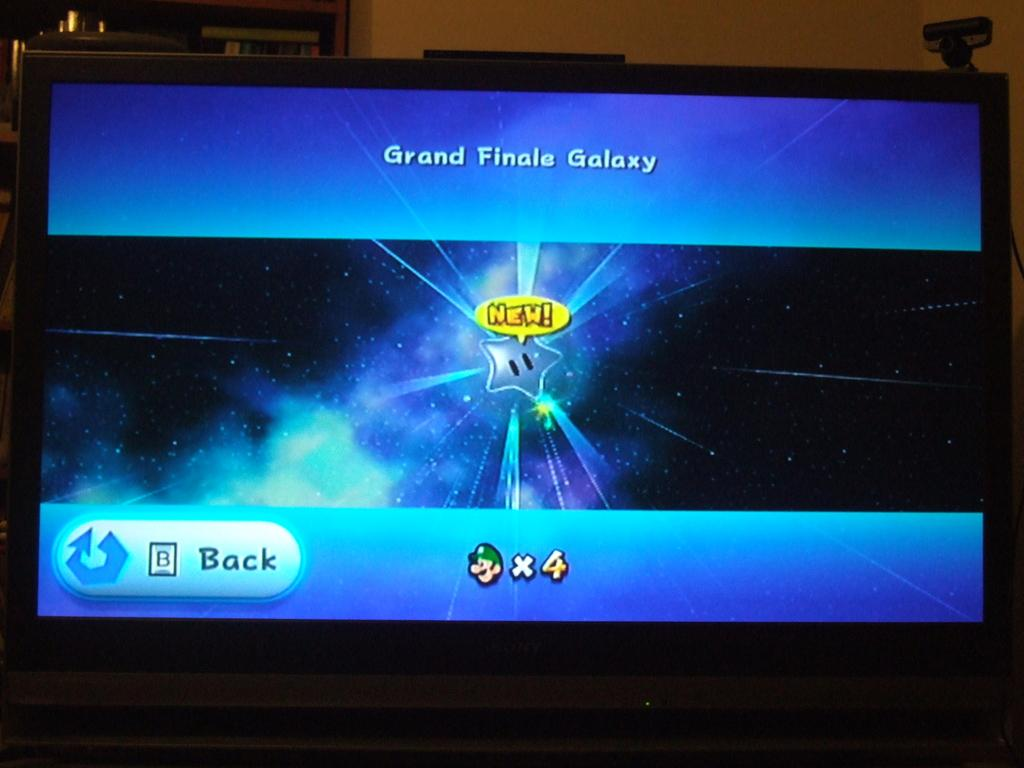Provide a one-sentence caption for the provided image. The screen of a game where you are at the Grand Finale Galaxy. 